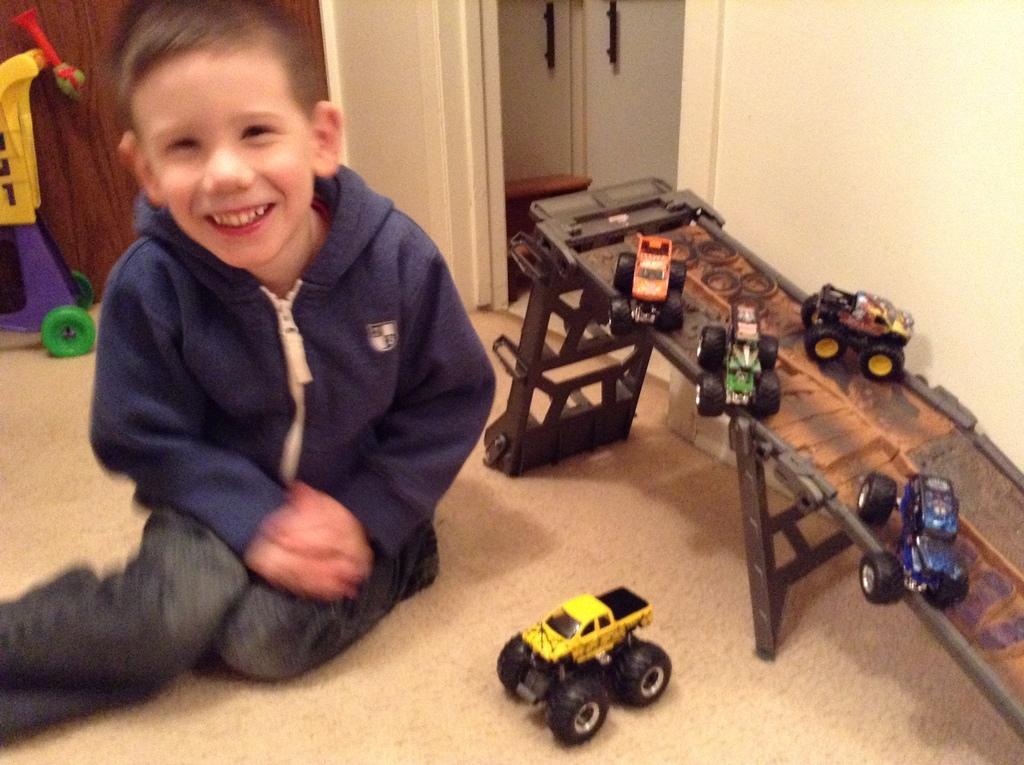Please provide a concise description of this image. In this picture we can see one boy is sitting on the floor and playing with toys. 